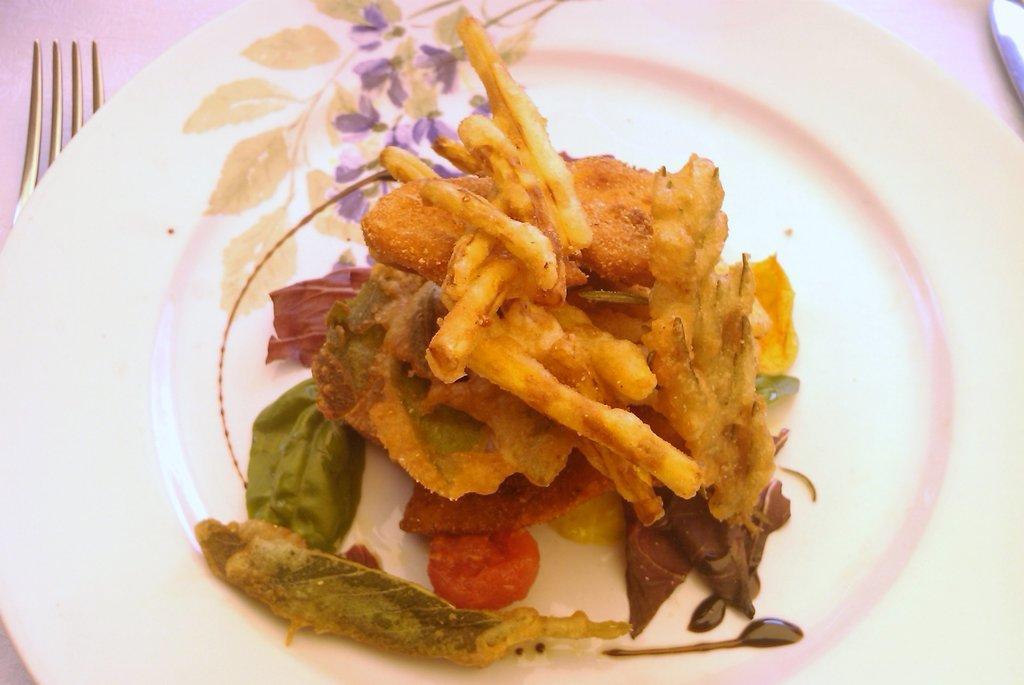How would you summarize this image in a sentence or two? In this picture we can see the food on a plate. On the left side of the picture we can see the partial part of a fork. On the right side of the picture we can see an object. 